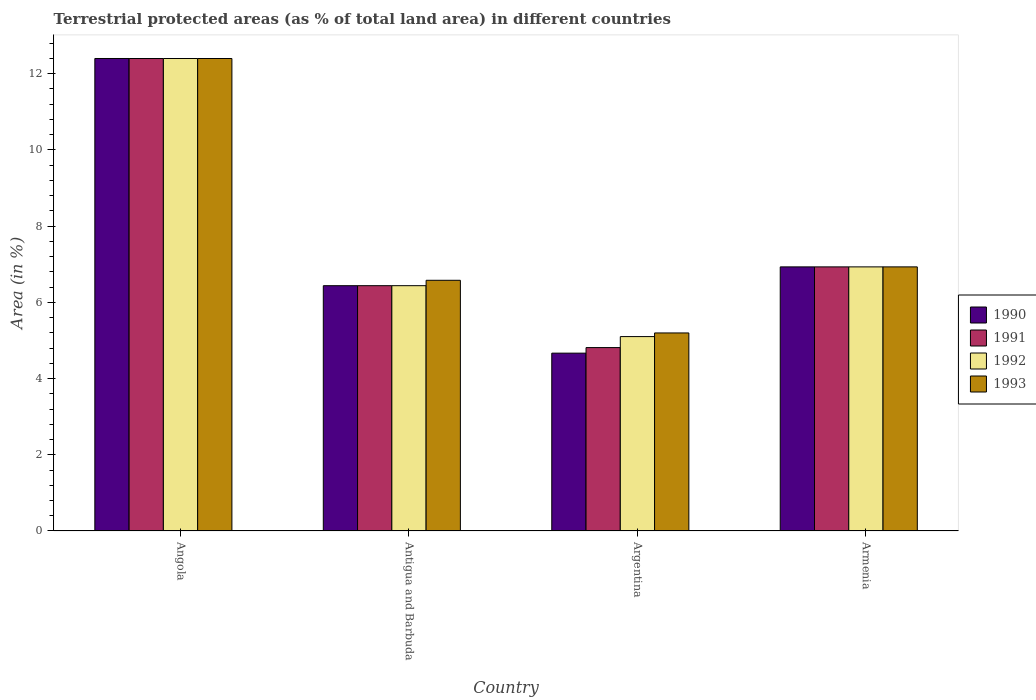What is the label of the 1st group of bars from the left?
Provide a succinct answer. Angola. In how many cases, is the number of bars for a given country not equal to the number of legend labels?
Your answer should be compact. 0. What is the percentage of terrestrial protected land in 1993 in Angola?
Give a very brief answer. 12.4. Across all countries, what is the maximum percentage of terrestrial protected land in 1991?
Your answer should be very brief. 12.4. Across all countries, what is the minimum percentage of terrestrial protected land in 1990?
Your answer should be very brief. 4.67. In which country was the percentage of terrestrial protected land in 1991 maximum?
Give a very brief answer. Angola. What is the total percentage of terrestrial protected land in 1993 in the graph?
Provide a succinct answer. 31.11. What is the difference between the percentage of terrestrial protected land in 1991 in Angola and that in Antigua and Barbuda?
Provide a succinct answer. 5.96. What is the difference between the percentage of terrestrial protected land in 1993 in Armenia and the percentage of terrestrial protected land in 1990 in Angola?
Keep it short and to the point. -5.47. What is the average percentage of terrestrial protected land in 1990 per country?
Your response must be concise. 7.61. What is the difference between the percentage of terrestrial protected land of/in 1991 and percentage of terrestrial protected land of/in 1990 in Armenia?
Ensure brevity in your answer.  -3.725521484021499e-5. In how many countries, is the percentage of terrestrial protected land in 1992 greater than 7.6 %?
Your response must be concise. 1. What is the ratio of the percentage of terrestrial protected land in 1991 in Antigua and Barbuda to that in Argentina?
Your answer should be compact. 1.34. Is the percentage of terrestrial protected land in 1993 in Angola less than that in Argentina?
Make the answer very short. No. Is the difference between the percentage of terrestrial protected land in 1991 in Angola and Argentina greater than the difference between the percentage of terrestrial protected land in 1990 in Angola and Argentina?
Keep it short and to the point. No. What is the difference between the highest and the second highest percentage of terrestrial protected land in 1993?
Provide a succinct answer. 5.47. What is the difference between the highest and the lowest percentage of terrestrial protected land in 1991?
Your answer should be compact. 7.59. Is the sum of the percentage of terrestrial protected land in 1991 in Angola and Armenia greater than the maximum percentage of terrestrial protected land in 1990 across all countries?
Provide a succinct answer. Yes. Is it the case that in every country, the sum of the percentage of terrestrial protected land in 1990 and percentage of terrestrial protected land in 1993 is greater than the sum of percentage of terrestrial protected land in 1991 and percentage of terrestrial protected land in 1992?
Your response must be concise. No. How many countries are there in the graph?
Your response must be concise. 4. What is the difference between two consecutive major ticks on the Y-axis?
Offer a terse response. 2. Where does the legend appear in the graph?
Offer a terse response. Center right. How many legend labels are there?
Make the answer very short. 4. What is the title of the graph?
Your response must be concise. Terrestrial protected areas (as % of total land area) in different countries. What is the label or title of the Y-axis?
Offer a very short reply. Area (in %). What is the Area (in %) of 1990 in Angola?
Provide a succinct answer. 12.4. What is the Area (in %) in 1991 in Angola?
Provide a short and direct response. 12.4. What is the Area (in %) in 1992 in Angola?
Provide a succinct answer. 12.4. What is the Area (in %) of 1993 in Angola?
Your answer should be compact. 12.4. What is the Area (in %) of 1990 in Antigua and Barbuda?
Provide a short and direct response. 6.44. What is the Area (in %) in 1991 in Antigua and Barbuda?
Provide a short and direct response. 6.44. What is the Area (in %) of 1992 in Antigua and Barbuda?
Provide a succinct answer. 6.44. What is the Area (in %) in 1993 in Antigua and Barbuda?
Keep it short and to the point. 6.58. What is the Area (in %) in 1990 in Argentina?
Keep it short and to the point. 4.67. What is the Area (in %) in 1991 in Argentina?
Ensure brevity in your answer.  4.81. What is the Area (in %) of 1992 in Argentina?
Keep it short and to the point. 5.1. What is the Area (in %) in 1993 in Argentina?
Provide a short and direct response. 5.2. What is the Area (in %) in 1990 in Armenia?
Make the answer very short. 6.93. What is the Area (in %) of 1991 in Armenia?
Keep it short and to the point. 6.93. What is the Area (in %) of 1992 in Armenia?
Provide a succinct answer. 6.93. What is the Area (in %) of 1993 in Armenia?
Offer a very short reply. 6.93. Across all countries, what is the maximum Area (in %) of 1990?
Ensure brevity in your answer.  12.4. Across all countries, what is the maximum Area (in %) of 1991?
Offer a terse response. 12.4. Across all countries, what is the maximum Area (in %) of 1992?
Offer a very short reply. 12.4. Across all countries, what is the maximum Area (in %) of 1993?
Your answer should be compact. 12.4. Across all countries, what is the minimum Area (in %) in 1990?
Provide a succinct answer. 4.67. Across all countries, what is the minimum Area (in %) in 1991?
Provide a short and direct response. 4.81. Across all countries, what is the minimum Area (in %) of 1992?
Provide a succinct answer. 5.1. Across all countries, what is the minimum Area (in %) of 1993?
Ensure brevity in your answer.  5.2. What is the total Area (in %) in 1990 in the graph?
Make the answer very short. 30.44. What is the total Area (in %) of 1991 in the graph?
Make the answer very short. 30.58. What is the total Area (in %) in 1992 in the graph?
Make the answer very short. 30.87. What is the total Area (in %) in 1993 in the graph?
Your answer should be very brief. 31.11. What is the difference between the Area (in %) in 1990 in Angola and that in Antigua and Barbuda?
Provide a short and direct response. 5.96. What is the difference between the Area (in %) in 1991 in Angola and that in Antigua and Barbuda?
Provide a short and direct response. 5.96. What is the difference between the Area (in %) in 1992 in Angola and that in Antigua and Barbuda?
Provide a short and direct response. 5.96. What is the difference between the Area (in %) of 1993 in Angola and that in Antigua and Barbuda?
Provide a short and direct response. 5.82. What is the difference between the Area (in %) of 1990 in Angola and that in Argentina?
Provide a succinct answer. 7.73. What is the difference between the Area (in %) in 1991 in Angola and that in Argentina?
Make the answer very short. 7.59. What is the difference between the Area (in %) in 1992 in Angola and that in Argentina?
Your answer should be very brief. 7.3. What is the difference between the Area (in %) in 1993 in Angola and that in Argentina?
Provide a short and direct response. 7.2. What is the difference between the Area (in %) in 1990 in Angola and that in Armenia?
Provide a short and direct response. 5.47. What is the difference between the Area (in %) of 1991 in Angola and that in Armenia?
Provide a succinct answer. 5.47. What is the difference between the Area (in %) in 1992 in Angola and that in Armenia?
Provide a succinct answer. 5.47. What is the difference between the Area (in %) of 1993 in Angola and that in Armenia?
Give a very brief answer. 5.47. What is the difference between the Area (in %) in 1990 in Antigua and Barbuda and that in Argentina?
Your answer should be compact. 1.77. What is the difference between the Area (in %) in 1991 in Antigua and Barbuda and that in Argentina?
Offer a very short reply. 1.62. What is the difference between the Area (in %) of 1992 in Antigua and Barbuda and that in Argentina?
Your answer should be compact. 1.34. What is the difference between the Area (in %) in 1993 in Antigua and Barbuda and that in Argentina?
Your answer should be compact. 1.38. What is the difference between the Area (in %) in 1990 in Antigua and Barbuda and that in Armenia?
Your answer should be compact. -0.49. What is the difference between the Area (in %) of 1991 in Antigua and Barbuda and that in Armenia?
Keep it short and to the point. -0.49. What is the difference between the Area (in %) in 1992 in Antigua and Barbuda and that in Armenia?
Keep it short and to the point. -0.49. What is the difference between the Area (in %) in 1993 in Antigua and Barbuda and that in Armenia?
Give a very brief answer. -0.35. What is the difference between the Area (in %) in 1990 in Argentina and that in Armenia?
Provide a succinct answer. -2.26. What is the difference between the Area (in %) in 1991 in Argentina and that in Armenia?
Provide a short and direct response. -2.12. What is the difference between the Area (in %) of 1992 in Argentina and that in Armenia?
Keep it short and to the point. -1.83. What is the difference between the Area (in %) in 1993 in Argentina and that in Armenia?
Provide a succinct answer. -1.73. What is the difference between the Area (in %) in 1990 in Angola and the Area (in %) in 1991 in Antigua and Barbuda?
Provide a succinct answer. 5.96. What is the difference between the Area (in %) of 1990 in Angola and the Area (in %) of 1992 in Antigua and Barbuda?
Offer a very short reply. 5.96. What is the difference between the Area (in %) in 1990 in Angola and the Area (in %) in 1993 in Antigua and Barbuda?
Provide a short and direct response. 5.82. What is the difference between the Area (in %) in 1991 in Angola and the Area (in %) in 1992 in Antigua and Barbuda?
Offer a terse response. 5.96. What is the difference between the Area (in %) in 1991 in Angola and the Area (in %) in 1993 in Antigua and Barbuda?
Give a very brief answer. 5.82. What is the difference between the Area (in %) of 1992 in Angola and the Area (in %) of 1993 in Antigua and Barbuda?
Make the answer very short. 5.82. What is the difference between the Area (in %) in 1990 in Angola and the Area (in %) in 1991 in Argentina?
Provide a succinct answer. 7.59. What is the difference between the Area (in %) in 1990 in Angola and the Area (in %) in 1992 in Argentina?
Offer a terse response. 7.3. What is the difference between the Area (in %) in 1990 in Angola and the Area (in %) in 1993 in Argentina?
Provide a short and direct response. 7.2. What is the difference between the Area (in %) in 1991 in Angola and the Area (in %) in 1992 in Argentina?
Keep it short and to the point. 7.3. What is the difference between the Area (in %) in 1991 in Angola and the Area (in %) in 1993 in Argentina?
Give a very brief answer. 7.2. What is the difference between the Area (in %) of 1992 in Angola and the Area (in %) of 1993 in Argentina?
Ensure brevity in your answer.  7.2. What is the difference between the Area (in %) in 1990 in Angola and the Area (in %) in 1991 in Armenia?
Keep it short and to the point. 5.47. What is the difference between the Area (in %) of 1990 in Angola and the Area (in %) of 1992 in Armenia?
Your answer should be very brief. 5.47. What is the difference between the Area (in %) of 1990 in Angola and the Area (in %) of 1993 in Armenia?
Offer a very short reply. 5.47. What is the difference between the Area (in %) of 1991 in Angola and the Area (in %) of 1992 in Armenia?
Provide a succinct answer. 5.47. What is the difference between the Area (in %) in 1991 in Angola and the Area (in %) in 1993 in Armenia?
Give a very brief answer. 5.47. What is the difference between the Area (in %) of 1992 in Angola and the Area (in %) of 1993 in Armenia?
Your answer should be very brief. 5.47. What is the difference between the Area (in %) of 1990 in Antigua and Barbuda and the Area (in %) of 1991 in Argentina?
Provide a short and direct response. 1.62. What is the difference between the Area (in %) in 1990 in Antigua and Barbuda and the Area (in %) in 1992 in Argentina?
Offer a very short reply. 1.34. What is the difference between the Area (in %) in 1990 in Antigua and Barbuda and the Area (in %) in 1993 in Argentina?
Keep it short and to the point. 1.24. What is the difference between the Area (in %) in 1991 in Antigua and Barbuda and the Area (in %) in 1992 in Argentina?
Give a very brief answer. 1.34. What is the difference between the Area (in %) in 1991 in Antigua and Barbuda and the Area (in %) in 1993 in Argentina?
Your response must be concise. 1.24. What is the difference between the Area (in %) of 1992 in Antigua and Barbuda and the Area (in %) of 1993 in Argentina?
Keep it short and to the point. 1.24. What is the difference between the Area (in %) of 1990 in Antigua and Barbuda and the Area (in %) of 1991 in Armenia?
Your answer should be compact. -0.49. What is the difference between the Area (in %) in 1990 in Antigua and Barbuda and the Area (in %) in 1992 in Armenia?
Ensure brevity in your answer.  -0.49. What is the difference between the Area (in %) of 1990 in Antigua and Barbuda and the Area (in %) of 1993 in Armenia?
Ensure brevity in your answer.  -0.49. What is the difference between the Area (in %) in 1991 in Antigua and Barbuda and the Area (in %) in 1992 in Armenia?
Your answer should be very brief. -0.49. What is the difference between the Area (in %) in 1991 in Antigua and Barbuda and the Area (in %) in 1993 in Armenia?
Keep it short and to the point. -0.49. What is the difference between the Area (in %) in 1992 in Antigua and Barbuda and the Area (in %) in 1993 in Armenia?
Provide a short and direct response. -0.49. What is the difference between the Area (in %) of 1990 in Argentina and the Area (in %) of 1991 in Armenia?
Offer a terse response. -2.26. What is the difference between the Area (in %) of 1990 in Argentina and the Area (in %) of 1992 in Armenia?
Make the answer very short. -2.26. What is the difference between the Area (in %) in 1990 in Argentina and the Area (in %) in 1993 in Armenia?
Offer a terse response. -2.26. What is the difference between the Area (in %) in 1991 in Argentina and the Area (in %) in 1992 in Armenia?
Give a very brief answer. -2.12. What is the difference between the Area (in %) of 1991 in Argentina and the Area (in %) of 1993 in Armenia?
Your answer should be compact. -2.12. What is the difference between the Area (in %) of 1992 in Argentina and the Area (in %) of 1993 in Armenia?
Ensure brevity in your answer.  -1.83. What is the average Area (in %) of 1990 per country?
Ensure brevity in your answer.  7.61. What is the average Area (in %) of 1991 per country?
Your answer should be compact. 7.65. What is the average Area (in %) in 1992 per country?
Give a very brief answer. 7.72. What is the average Area (in %) of 1993 per country?
Make the answer very short. 7.78. What is the difference between the Area (in %) in 1990 and Area (in %) in 1991 in Angola?
Your response must be concise. 0. What is the difference between the Area (in %) of 1990 and Area (in %) of 1992 in Angola?
Ensure brevity in your answer.  0. What is the difference between the Area (in %) in 1990 and Area (in %) in 1993 in Angola?
Your response must be concise. 0. What is the difference between the Area (in %) in 1991 and Area (in %) in 1993 in Angola?
Provide a short and direct response. 0. What is the difference between the Area (in %) of 1990 and Area (in %) of 1991 in Antigua and Barbuda?
Provide a succinct answer. -0. What is the difference between the Area (in %) in 1990 and Area (in %) in 1992 in Antigua and Barbuda?
Ensure brevity in your answer.  -0. What is the difference between the Area (in %) in 1990 and Area (in %) in 1993 in Antigua and Barbuda?
Make the answer very short. -0.14. What is the difference between the Area (in %) in 1991 and Area (in %) in 1992 in Antigua and Barbuda?
Keep it short and to the point. 0. What is the difference between the Area (in %) of 1991 and Area (in %) of 1993 in Antigua and Barbuda?
Your answer should be compact. -0.14. What is the difference between the Area (in %) of 1992 and Area (in %) of 1993 in Antigua and Barbuda?
Your response must be concise. -0.14. What is the difference between the Area (in %) of 1990 and Area (in %) of 1991 in Argentina?
Your answer should be compact. -0.15. What is the difference between the Area (in %) of 1990 and Area (in %) of 1992 in Argentina?
Your answer should be compact. -0.43. What is the difference between the Area (in %) of 1990 and Area (in %) of 1993 in Argentina?
Offer a terse response. -0.53. What is the difference between the Area (in %) in 1991 and Area (in %) in 1992 in Argentina?
Your answer should be compact. -0.29. What is the difference between the Area (in %) in 1991 and Area (in %) in 1993 in Argentina?
Your response must be concise. -0.38. What is the difference between the Area (in %) of 1992 and Area (in %) of 1993 in Argentina?
Give a very brief answer. -0.1. What is the difference between the Area (in %) in 1990 and Area (in %) in 1993 in Armenia?
Offer a terse response. 0. What is the ratio of the Area (in %) in 1990 in Angola to that in Antigua and Barbuda?
Give a very brief answer. 1.93. What is the ratio of the Area (in %) in 1991 in Angola to that in Antigua and Barbuda?
Provide a short and direct response. 1.93. What is the ratio of the Area (in %) in 1992 in Angola to that in Antigua and Barbuda?
Your response must be concise. 1.93. What is the ratio of the Area (in %) in 1993 in Angola to that in Antigua and Barbuda?
Your response must be concise. 1.88. What is the ratio of the Area (in %) in 1990 in Angola to that in Argentina?
Ensure brevity in your answer.  2.66. What is the ratio of the Area (in %) of 1991 in Angola to that in Argentina?
Your answer should be compact. 2.58. What is the ratio of the Area (in %) of 1992 in Angola to that in Argentina?
Provide a short and direct response. 2.43. What is the ratio of the Area (in %) in 1993 in Angola to that in Argentina?
Offer a very short reply. 2.39. What is the ratio of the Area (in %) in 1990 in Angola to that in Armenia?
Provide a succinct answer. 1.79. What is the ratio of the Area (in %) of 1991 in Angola to that in Armenia?
Make the answer very short. 1.79. What is the ratio of the Area (in %) in 1992 in Angola to that in Armenia?
Your answer should be compact. 1.79. What is the ratio of the Area (in %) of 1993 in Angola to that in Armenia?
Give a very brief answer. 1.79. What is the ratio of the Area (in %) in 1990 in Antigua and Barbuda to that in Argentina?
Offer a very short reply. 1.38. What is the ratio of the Area (in %) in 1991 in Antigua and Barbuda to that in Argentina?
Your answer should be very brief. 1.34. What is the ratio of the Area (in %) in 1992 in Antigua and Barbuda to that in Argentina?
Keep it short and to the point. 1.26. What is the ratio of the Area (in %) in 1993 in Antigua and Barbuda to that in Argentina?
Provide a succinct answer. 1.27. What is the ratio of the Area (in %) of 1990 in Antigua and Barbuda to that in Armenia?
Your response must be concise. 0.93. What is the ratio of the Area (in %) in 1991 in Antigua and Barbuda to that in Armenia?
Give a very brief answer. 0.93. What is the ratio of the Area (in %) in 1992 in Antigua and Barbuda to that in Armenia?
Keep it short and to the point. 0.93. What is the ratio of the Area (in %) of 1993 in Antigua and Barbuda to that in Armenia?
Provide a succinct answer. 0.95. What is the ratio of the Area (in %) in 1990 in Argentina to that in Armenia?
Offer a terse response. 0.67. What is the ratio of the Area (in %) of 1991 in Argentina to that in Armenia?
Make the answer very short. 0.69. What is the ratio of the Area (in %) of 1992 in Argentina to that in Armenia?
Give a very brief answer. 0.74. What is the ratio of the Area (in %) in 1993 in Argentina to that in Armenia?
Keep it short and to the point. 0.75. What is the difference between the highest and the second highest Area (in %) in 1990?
Your answer should be compact. 5.47. What is the difference between the highest and the second highest Area (in %) of 1991?
Offer a terse response. 5.47. What is the difference between the highest and the second highest Area (in %) of 1992?
Provide a succinct answer. 5.47. What is the difference between the highest and the second highest Area (in %) in 1993?
Your response must be concise. 5.47. What is the difference between the highest and the lowest Area (in %) of 1990?
Provide a short and direct response. 7.73. What is the difference between the highest and the lowest Area (in %) in 1991?
Provide a succinct answer. 7.59. What is the difference between the highest and the lowest Area (in %) in 1992?
Offer a very short reply. 7.3. What is the difference between the highest and the lowest Area (in %) in 1993?
Your response must be concise. 7.2. 